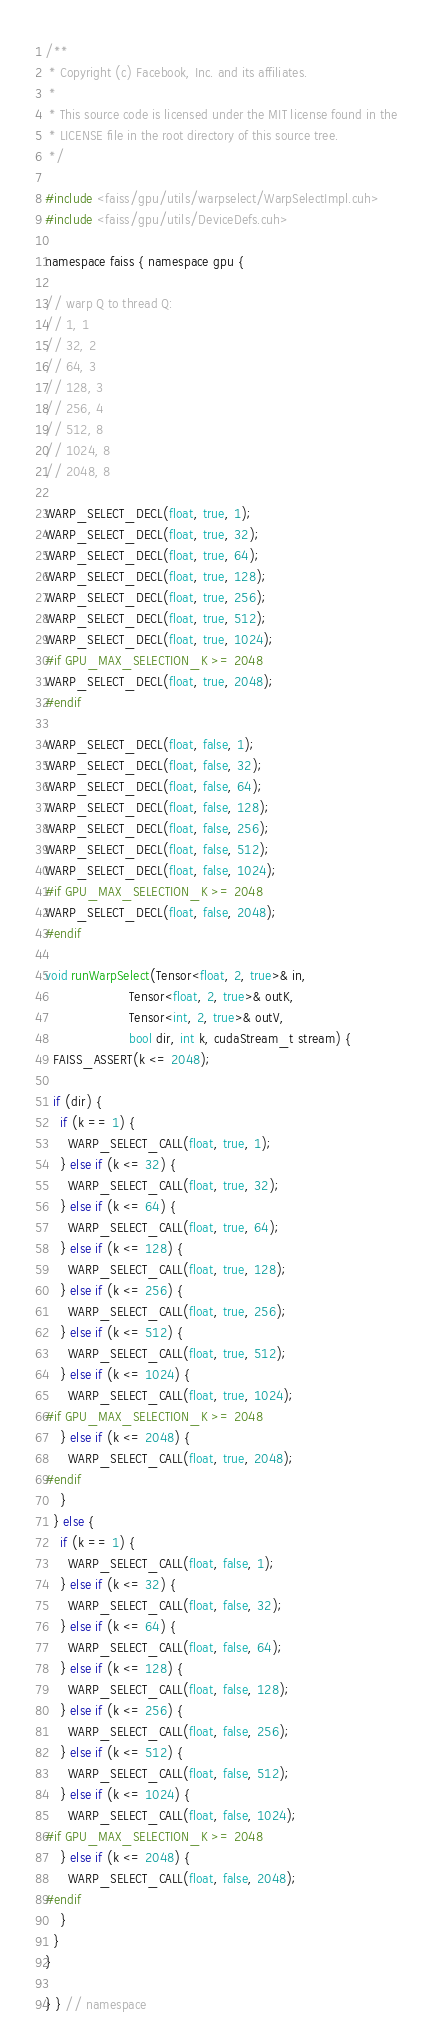<code> <loc_0><loc_0><loc_500><loc_500><_Cuda_>/**
 * Copyright (c) Facebook, Inc. and its affiliates.
 *
 * This source code is licensed under the MIT license found in the
 * LICENSE file in the root directory of this source tree.
 */

#include <faiss/gpu/utils/warpselect/WarpSelectImpl.cuh>
#include <faiss/gpu/utils/DeviceDefs.cuh>

namespace faiss { namespace gpu {

// warp Q to thread Q:
// 1, 1
// 32, 2
// 64, 3
// 128, 3
// 256, 4
// 512, 8
// 1024, 8
// 2048, 8

WARP_SELECT_DECL(float, true, 1);
WARP_SELECT_DECL(float, true, 32);
WARP_SELECT_DECL(float, true, 64);
WARP_SELECT_DECL(float, true, 128);
WARP_SELECT_DECL(float, true, 256);
WARP_SELECT_DECL(float, true, 512);
WARP_SELECT_DECL(float, true, 1024);
#if GPU_MAX_SELECTION_K >= 2048
WARP_SELECT_DECL(float, true, 2048);
#endif

WARP_SELECT_DECL(float, false, 1);
WARP_SELECT_DECL(float, false, 32);
WARP_SELECT_DECL(float, false, 64);
WARP_SELECT_DECL(float, false, 128);
WARP_SELECT_DECL(float, false, 256);
WARP_SELECT_DECL(float, false, 512);
WARP_SELECT_DECL(float, false, 1024);
#if GPU_MAX_SELECTION_K >= 2048
WARP_SELECT_DECL(float, false, 2048);
#endif

void runWarpSelect(Tensor<float, 2, true>& in,
                      Tensor<float, 2, true>& outK,
                      Tensor<int, 2, true>& outV,
                      bool dir, int k, cudaStream_t stream) {
  FAISS_ASSERT(k <= 2048);

  if (dir) {
    if (k == 1) {
      WARP_SELECT_CALL(float, true, 1);
    } else if (k <= 32) {
      WARP_SELECT_CALL(float, true, 32);
    } else if (k <= 64) {
      WARP_SELECT_CALL(float, true, 64);
    } else if (k <= 128) {
      WARP_SELECT_CALL(float, true, 128);
    } else if (k <= 256) {
      WARP_SELECT_CALL(float, true, 256);
    } else if (k <= 512) {
      WARP_SELECT_CALL(float, true, 512);
    } else if (k <= 1024) {
      WARP_SELECT_CALL(float, true, 1024);
#if GPU_MAX_SELECTION_K >= 2048
    } else if (k <= 2048) {
      WARP_SELECT_CALL(float, true, 2048);
#endif
    }
  } else {
    if (k == 1) {
      WARP_SELECT_CALL(float, false, 1);
    } else if (k <= 32) {
      WARP_SELECT_CALL(float, false, 32);
    } else if (k <= 64) {
      WARP_SELECT_CALL(float, false, 64);
    } else if (k <= 128) {
      WARP_SELECT_CALL(float, false, 128);
    } else if (k <= 256) {
      WARP_SELECT_CALL(float, false, 256);
    } else if (k <= 512) {
      WARP_SELECT_CALL(float, false, 512);
    } else if (k <= 1024) {
      WARP_SELECT_CALL(float, false, 1024);
#if GPU_MAX_SELECTION_K >= 2048
    } else if (k <= 2048) {
      WARP_SELECT_CALL(float, false, 2048);
#endif
    }
  }
}

} } // namespace
</code> 